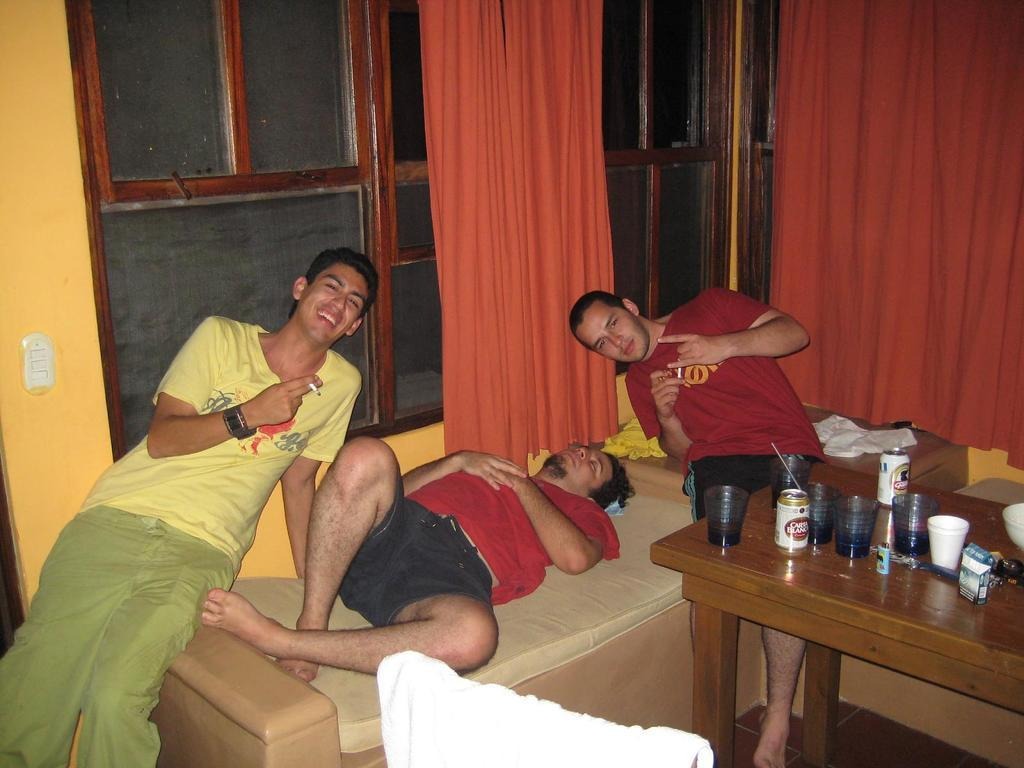What is the man in the image doing? There is a man sleeping on the bed in the image. How many men are sitting on the bed? There are two men sitting on the bed. What objects can be seen on the table? There are glasses, cups, and a tin on the table. What is visible in the background of the image? There is a window, a curtain, and a wall in the background. What type of wood can be seen in the image? There is no wood visible in the image. Is there an owl present in the image? No, there is no owl present in the image. 